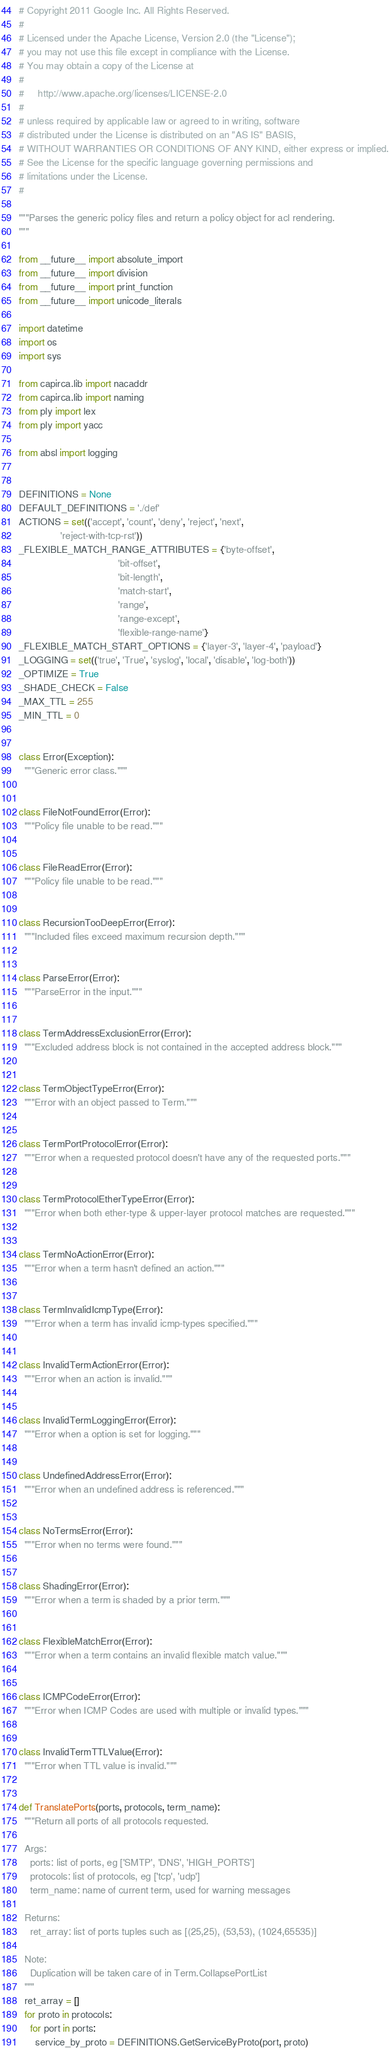<code> <loc_0><loc_0><loc_500><loc_500><_Python_># Copyright 2011 Google Inc. All Rights Reserved.
#
# Licensed under the Apache License, Version 2.0 (the "License");
# you may not use this file except in compliance with the License.
# You may obtain a copy of the License at
#
#     http://www.apache.org/licenses/LICENSE-2.0
#
# unless required by applicable law or agreed to in writing, software
# distributed under the License is distributed on an "AS IS" BASIS,
# WITHOUT WARRANTIES OR CONDITIONS OF ANY KIND, either express or implied.
# See the License for the specific language governing permissions and
# limitations under the License.
#

"""Parses the generic policy files and return a policy object for acl rendering.
"""

from __future__ import absolute_import
from __future__ import division
from __future__ import print_function
from __future__ import unicode_literals

import datetime
import os
import sys

from capirca.lib import nacaddr
from capirca.lib import naming
from ply import lex
from ply import yacc

from absl import logging


DEFINITIONS = None
DEFAULT_DEFINITIONS = './def'
ACTIONS = set(('accept', 'count', 'deny', 'reject', 'next',
               'reject-with-tcp-rst'))
_FLEXIBLE_MATCH_RANGE_ATTRIBUTES = {'byte-offset',
                                    'bit-offset',
                                    'bit-length',
                                    'match-start',
                                    'range',
                                    'range-except',
                                    'flexible-range-name'}
_FLEXIBLE_MATCH_START_OPTIONS = {'layer-3', 'layer-4', 'payload'}
_LOGGING = set(('true', 'True', 'syslog', 'local', 'disable', 'log-both'))
_OPTIMIZE = True
_SHADE_CHECK = False
_MAX_TTL = 255
_MIN_TTL = 0


class Error(Exception):
  """Generic error class."""


class FileNotFoundError(Error):
  """Policy file unable to be read."""


class FileReadError(Error):
  """Policy file unable to be read."""


class RecursionTooDeepError(Error):
  """Included files exceed maximum recursion depth."""


class ParseError(Error):
  """ParseError in the input."""


class TermAddressExclusionError(Error):
  """Excluded address block is not contained in the accepted address block."""


class TermObjectTypeError(Error):
  """Error with an object passed to Term."""


class TermPortProtocolError(Error):
  """Error when a requested protocol doesn't have any of the requested ports."""


class TermProtocolEtherTypeError(Error):
  """Error when both ether-type & upper-layer protocol matches are requested."""


class TermNoActionError(Error):
  """Error when a term hasn't defined an action."""


class TermInvalidIcmpType(Error):
  """Error when a term has invalid icmp-types specified."""


class InvalidTermActionError(Error):
  """Error when an action is invalid."""


class InvalidTermLoggingError(Error):
  """Error when a option is set for logging."""


class UndefinedAddressError(Error):
  """Error when an undefined address is referenced."""


class NoTermsError(Error):
  """Error when no terms were found."""


class ShadingError(Error):
  """Error when a term is shaded by a prior term."""


class FlexibleMatchError(Error):
  """Error when a term contains an invalid flexible match value."""


class ICMPCodeError(Error):
  """Error when ICMP Codes are used with multiple or invalid types."""


class InvalidTermTTLValue(Error):
  """Error when TTL value is invalid."""


def TranslatePorts(ports, protocols, term_name):
  """Return all ports of all protocols requested.

  Args:
    ports: list of ports, eg ['SMTP', 'DNS', 'HIGH_PORTS']
    protocols: list of protocols, eg ['tcp', 'udp']
    term_name: name of current term, used for warning messages

  Returns:
    ret_array: list of ports tuples such as [(25,25), (53,53), (1024,65535)]

  Note:
    Duplication will be taken care of in Term.CollapsePortList
  """
  ret_array = []
  for proto in protocols:
    for port in ports:
      service_by_proto = DEFINITIONS.GetServiceByProto(port, proto)</code> 